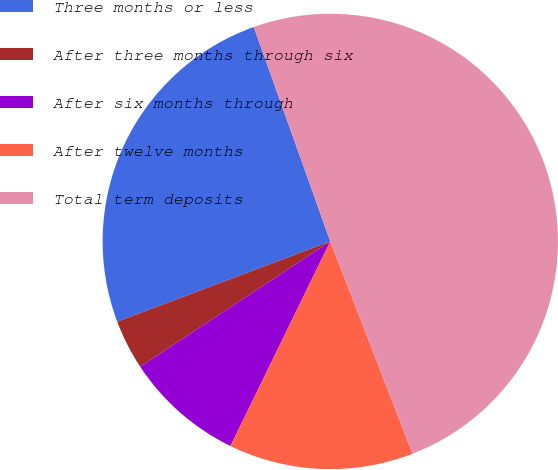Convert chart to OTSL. <chart><loc_0><loc_0><loc_500><loc_500><pie_chart><fcel>Three months or less<fcel>After three months through six<fcel>After six months through<fcel>After twelve months<fcel>Total term deposits<nl><fcel>25.28%<fcel>3.54%<fcel>8.5%<fcel>13.11%<fcel>49.57%<nl></chart> 